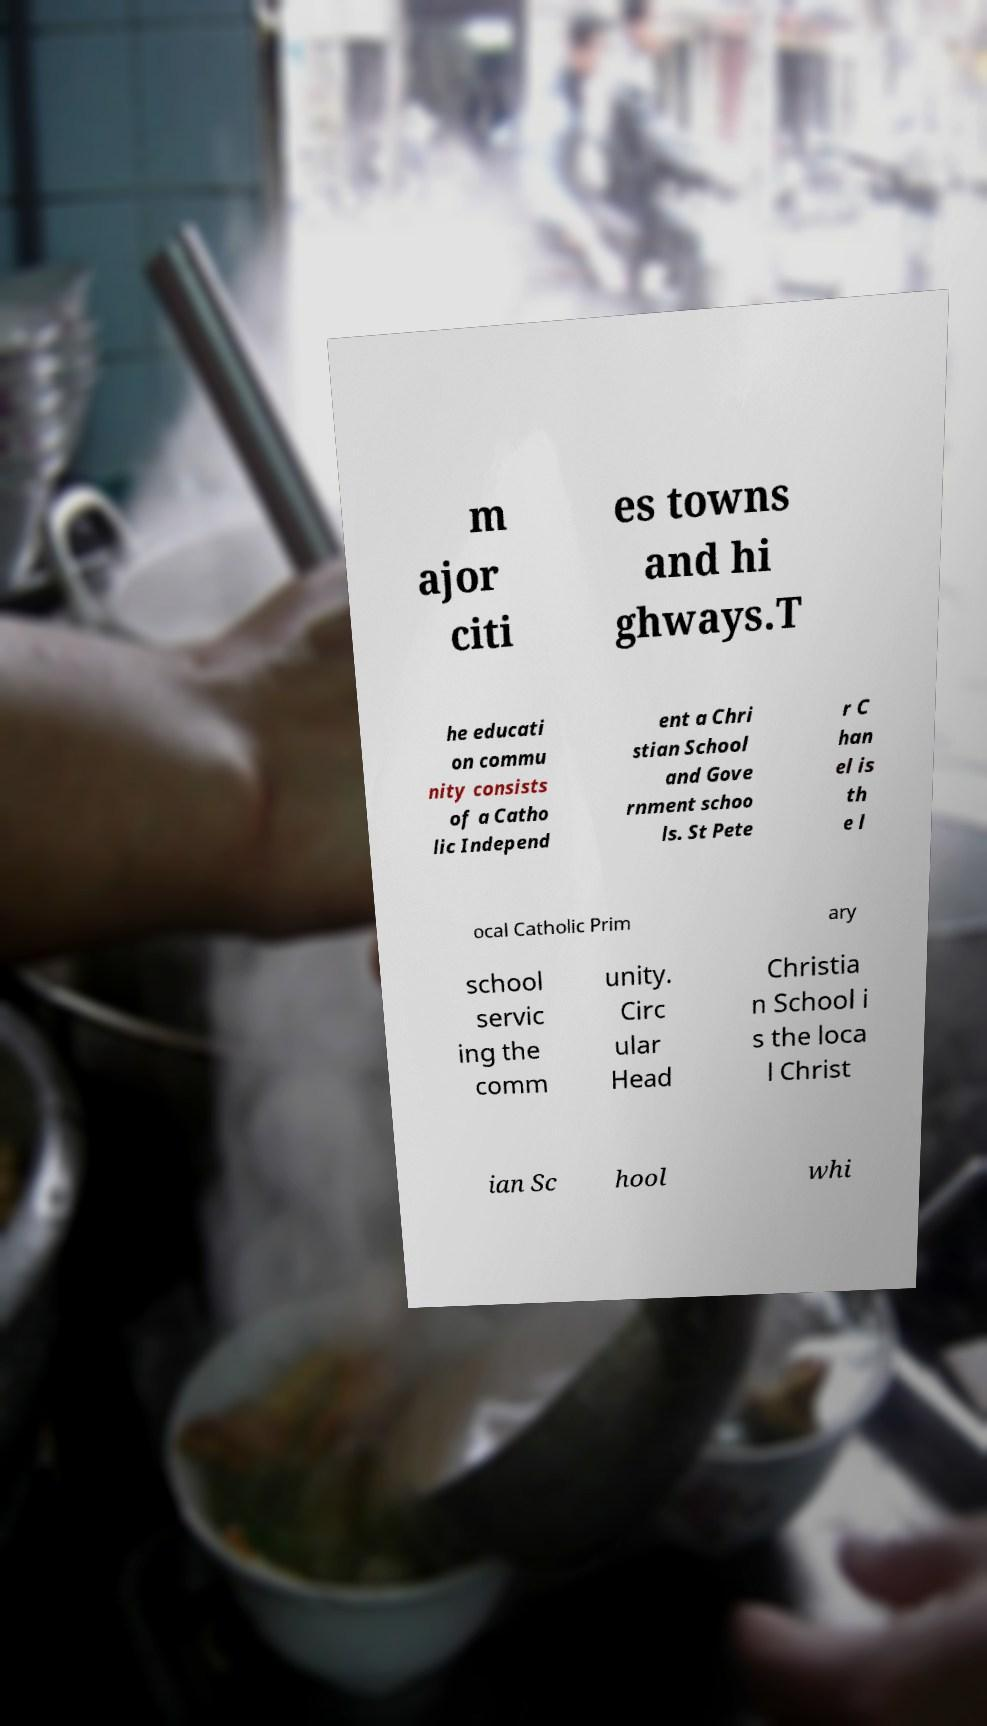For documentation purposes, I need the text within this image transcribed. Could you provide that? m ajor citi es towns and hi ghways.T he educati on commu nity consists of a Catho lic Independ ent a Chri stian School and Gove rnment schoo ls. St Pete r C han el is th e l ocal Catholic Prim ary school servic ing the comm unity. Circ ular Head Christia n School i s the loca l Christ ian Sc hool whi 